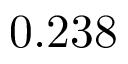Convert formula to latex. <formula><loc_0><loc_0><loc_500><loc_500>0 . 2 3 8</formula> 